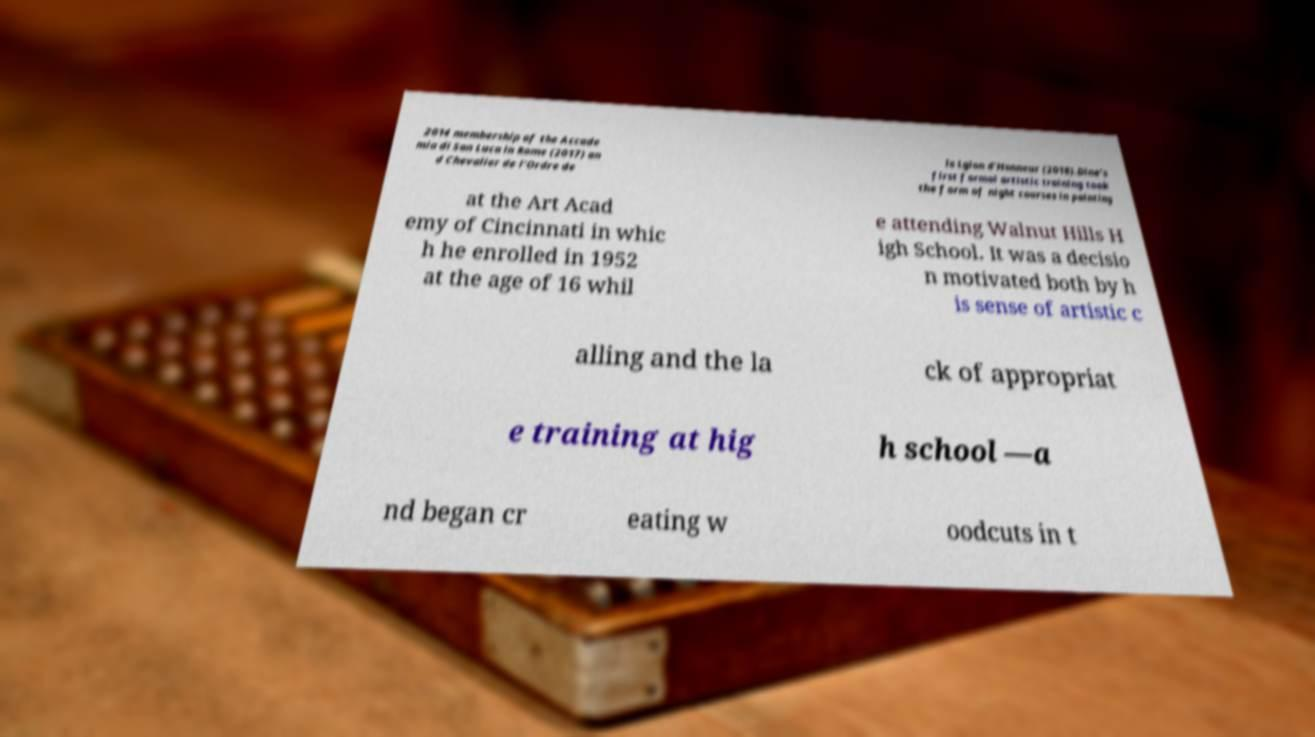Please read and relay the text visible in this image. What does it say? 2014 membership of the Accade mia di San Luca in Rome (2017) an d Chevalier de l'Ordre de la Lgion d'Honneur (2018).Dine’s first formal artistic training took the form of night courses in painting at the Art Acad emy of Cincinnati in whic h he enrolled in 1952 at the age of 16 whil e attending Walnut Hills H igh School. It was a decisio n motivated both by h is sense of artistic c alling and the la ck of appropriat e training at hig h school —a nd began cr eating w oodcuts in t 